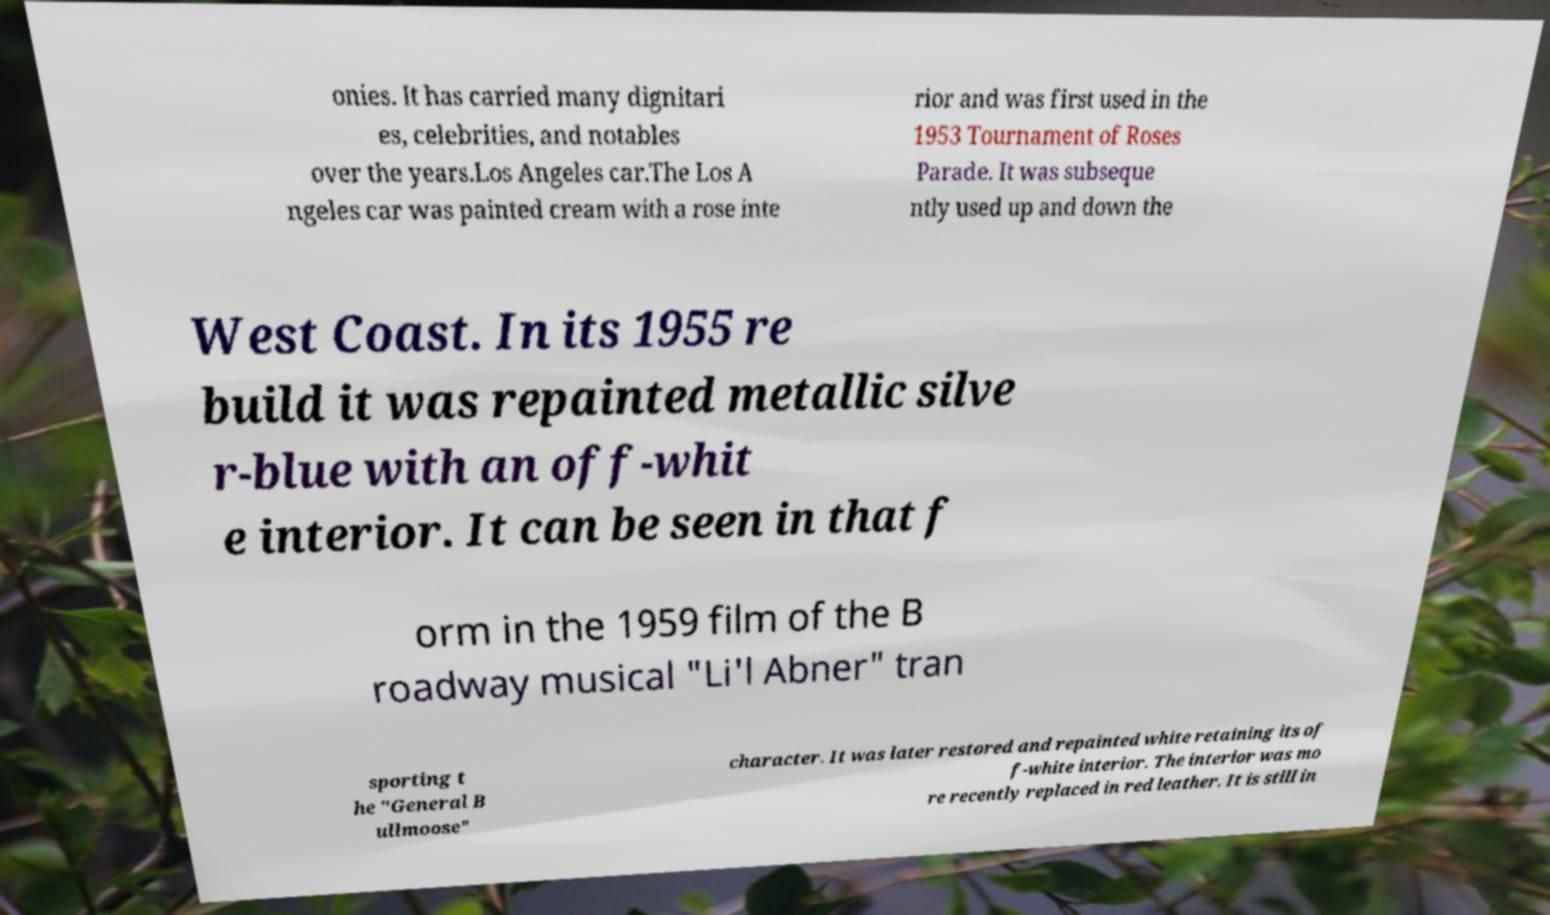Can you accurately transcribe the text from the provided image for me? onies. It has carried many dignitari es, celebrities, and notables over the years.Los Angeles car.The Los A ngeles car was painted cream with a rose inte rior and was first used in the 1953 Tournament of Roses Parade. It was subseque ntly used up and down the West Coast. In its 1955 re build it was repainted metallic silve r-blue with an off-whit e interior. It can be seen in that f orm in the 1959 film of the B roadway musical "Li'l Abner" tran sporting t he "General B ullmoose" character. It was later restored and repainted white retaining its of f-white interior. The interior was mo re recently replaced in red leather. It is still in 